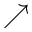<formula> <loc_0><loc_0><loc_500><loc_500>\nearrow</formula> 